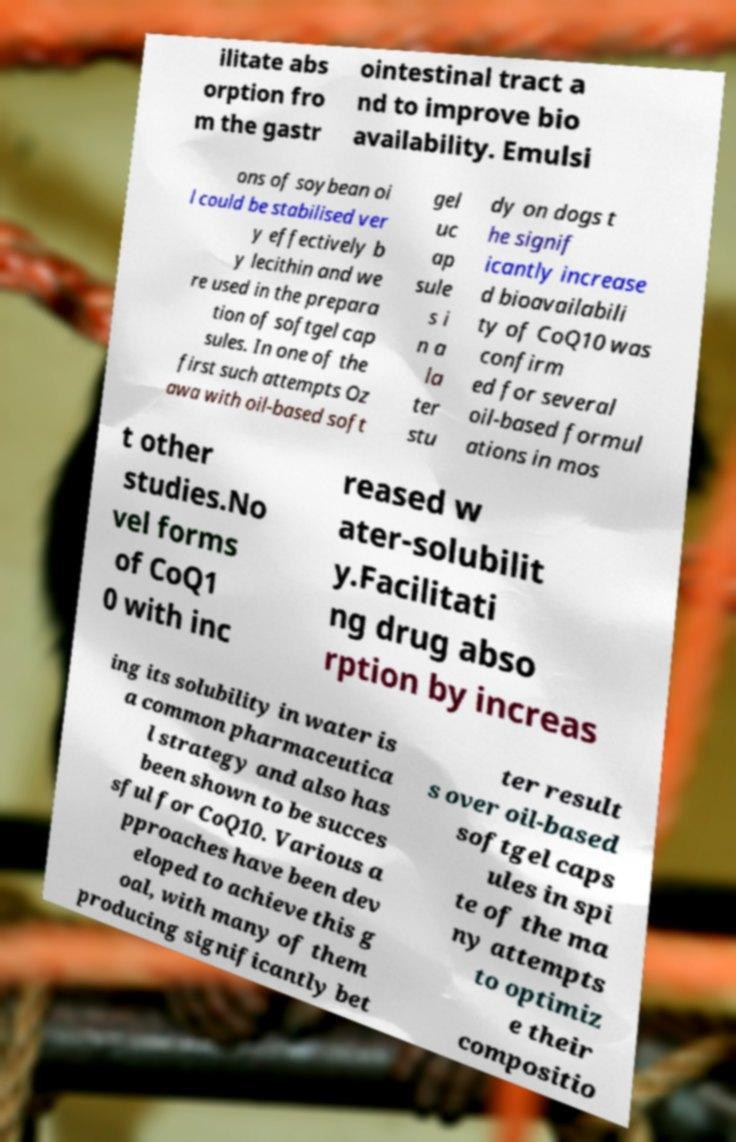Could you assist in decoding the text presented in this image and type it out clearly? ilitate abs orption fro m the gastr ointestinal tract a nd to improve bio availability. Emulsi ons of soybean oi l could be stabilised ver y effectively b y lecithin and we re used in the prepara tion of softgel cap sules. In one of the first such attempts Oz awa with oil-based soft gel uc ap sule s i n a la ter stu dy on dogs t he signif icantly increase d bioavailabili ty of CoQ10 was confirm ed for several oil-based formul ations in mos t other studies.No vel forms of CoQ1 0 with inc reased w ater-solubilit y.Facilitati ng drug abso rption by increas ing its solubility in water is a common pharmaceutica l strategy and also has been shown to be succes sful for CoQ10. Various a pproaches have been dev eloped to achieve this g oal, with many of them producing significantly bet ter result s over oil-based softgel caps ules in spi te of the ma ny attempts to optimiz e their compositio 